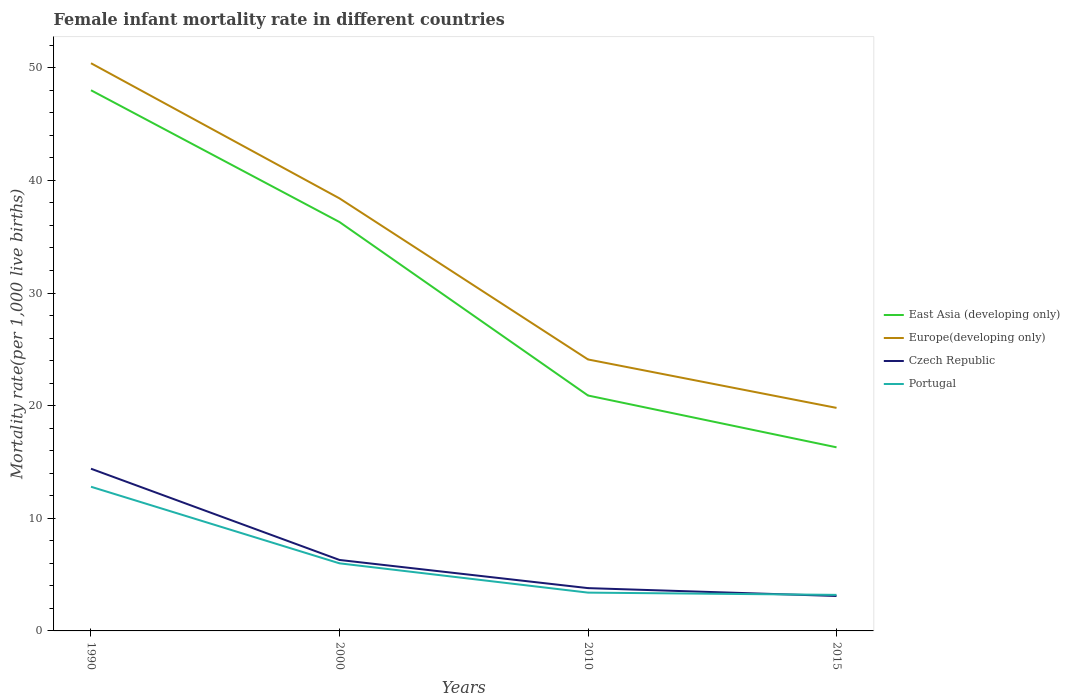Is the number of lines equal to the number of legend labels?
Offer a terse response. Yes. In which year was the female infant mortality rate in East Asia (developing only) maximum?
Your response must be concise. 2015. What is the total female infant mortality rate in Czech Republic in the graph?
Provide a short and direct response. 11.3. What is the difference between the highest and the second highest female infant mortality rate in Portugal?
Give a very brief answer. 9.6. Is the female infant mortality rate in East Asia (developing only) strictly greater than the female infant mortality rate in Portugal over the years?
Make the answer very short. No. How many lines are there?
Make the answer very short. 4. What is the difference between two consecutive major ticks on the Y-axis?
Ensure brevity in your answer.  10. Are the values on the major ticks of Y-axis written in scientific E-notation?
Offer a terse response. No. Does the graph contain any zero values?
Give a very brief answer. No. Does the graph contain grids?
Offer a terse response. No. Where does the legend appear in the graph?
Give a very brief answer. Center right. How many legend labels are there?
Make the answer very short. 4. What is the title of the graph?
Give a very brief answer. Female infant mortality rate in different countries. What is the label or title of the Y-axis?
Your answer should be compact. Mortality rate(per 1,0 live births). What is the Mortality rate(per 1,000 live births) of Europe(developing only) in 1990?
Make the answer very short. 50.4. What is the Mortality rate(per 1,000 live births) of Czech Republic in 1990?
Make the answer very short. 14.4. What is the Mortality rate(per 1,000 live births) of Portugal in 1990?
Give a very brief answer. 12.8. What is the Mortality rate(per 1,000 live births) of East Asia (developing only) in 2000?
Ensure brevity in your answer.  36.3. What is the Mortality rate(per 1,000 live births) of Europe(developing only) in 2000?
Your response must be concise. 38.4. What is the Mortality rate(per 1,000 live births) of Portugal in 2000?
Give a very brief answer. 6. What is the Mortality rate(per 1,000 live births) of East Asia (developing only) in 2010?
Provide a succinct answer. 20.9. What is the Mortality rate(per 1,000 live births) in Europe(developing only) in 2010?
Keep it short and to the point. 24.1. What is the Mortality rate(per 1,000 live births) of Czech Republic in 2010?
Offer a terse response. 3.8. What is the Mortality rate(per 1,000 live births) in East Asia (developing only) in 2015?
Provide a short and direct response. 16.3. What is the Mortality rate(per 1,000 live births) of Europe(developing only) in 2015?
Your answer should be very brief. 19.8. What is the Mortality rate(per 1,000 live births) of Czech Republic in 2015?
Offer a very short reply. 3.1. What is the Mortality rate(per 1,000 live births) in Portugal in 2015?
Make the answer very short. 3.2. Across all years, what is the maximum Mortality rate(per 1,000 live births) in Europe(developing only)?
Keep it short and to the point. 50.4. Across all years, what is the maximum Mortality rate(per 1,000 live births) in Czech Republic?
Offer a terse response. 14.4. Across all years, what is the maximum Mortality rate(per 1,000 live births) in Portugal?
Your response must be concise. 12.8. Across all years, what is the minimum Mortality rate(per 1,000 live births) of East Asia (developing only)?
Provide a short and direct response. 16.3. Across all years, what is the minimum Mortality rate(per 1,000 live births) in Europe(developing only)?
Ensure brevity in your answer.  19.8. Across all years, what is the minimum Mortality rate(per 1,000 live births) in Portugal?
Provide a short and direct response. 3.2. What is the total Mortality rate(per 1,000 live births) of East Asia (developing only) in the graph?
Provide a short and direct response. 121.5. What is the total Mortality rate(per 1,000 live births) of Europe(developing only) in the graph?
Give a very brief answer. 132.7. What is the total Mortality rate(per 1,000 live births) in Czech Republic in the graph?
Offer a very short reply. 27.6. What is the total Mortality rate(per 1,000 live births) in Portugal in the graph?
Your answer should be very brief. 25.4. What is the difference between the Mortality rate(per 1,000 live births) of East Asia (developing only) in 1990 and that in 2000?
Your answer should be very brief. 11.7. What is the difference between the Mortality rate(per 1,000 live births) in Europe(developing only) in 1990 and that in 2000?
Make the answer very short. 12. What is the difference between the Mortality rate(per 1,000 live births) in Portugal in 1990 and that in 2000?
Your response must be concise. 6.8. What is the difference between the Mortality rate(per 1,000 live births) in East Asia (developing only) in 1990 and that in 2010?
Your answer should be compact. 27.1. What is the difference between the Mortality rate(per 1,000 live births) of Europe(developing only) in 1990 and that in 2010?
Ensure brevity in your answer.  26.3. What is the difference between the Mortality rate(per 1,000 live births) in East Asia (developing only) in 1990 and that in 2015?
Your answer should be compact. 31.7. What is the difference between the Mortality rate(per 1,000 live births) of Europe(developing only) in 1990 and that in 2015?
Give a very brief answer. 30.6. What is the difference between the Mortality rate(per 1,000 live births) in Czech Republic in 1990 and that in 2015?
Provide a succinct answer. 11.3. What is the difference between the Mortality rate(per 1,000 live births) in East Asia (developing only) in 2000 and that in 2010?
Provide a succinct answer. 15.4. What is the difference between the Mortality rate(per 1,000 live births) in Europe(developing only) in 2000 and that in 2010?
Offer a very short reply. 14.3. What is the difference between the Mortality rate(per 1,000 live births) of Portugal in 2000 and that in 2010?
Provide a succinct answer. 2.6. What is the difference between the Mortality rate(per 1,000 live births) of East Asia (developing only) in 2000 and that in 2015?
Make the answer very short. 20. What is the difference between the Mortality rate(per 1,000 live births) of Europe(developing only) in 2000 and that in 2015?
Keep it short and to the point. 18.6. What is the difference between the Mortality rate(per 1,000 live births) of East Asia (developing only) in 2010 and that in 2015?
Keep it short and to the point. 4.6. What is the difference between the Mortality rate(per 1,000 live births) of Portugal in 2010 and that in 2015?
Keep it short and to the point. 0.2. What is the difference between the Mortality rate(per 1,000 live births) in East Asia (developing only) in 1990 and the Mortality rate(per 1,000 live births) in Europe(developing only) in 2000?
Your response must be concise. 9.6. What is the difference between the Mortality rate(per 1,000 live births) of East Asia (developing only) in 1990 and the Mortality rate(per 1,000 live births) of Czech Republic in 2000?
Your answer should be very brief. 41.7. What is the difference between the Mortality rate(per 1,000 live births) of East Asia (developing only) in 1990 and the Mortality rate(per 1,000 live births) of Portugal in 2000?
Make the answer very short. 42. What is the difference between the Mortality rate(per 1,000 live births) of Europe(developing only) in 1990 and the Mortality rate(per 1,000 live births) of Czech Republic in 2000?
Your response must be concise. 44.1. What is the difference between the Mortality rate(per 1,000 live births) of Europe(developing only) in 1990 and the Mortality rate(per 1,000 live births) of Portugal in 2000?
Ensure brevity in your answer.  44.4. What is the difference between the Mortality rate(per 1,000 live births) in East Asia (developing only) in 1990 and the Mortality rate(per 1,000 live births) in Europe(developing only) in 2010?
Your answer should be very brief. 23.9. What is the difference between the Mortality rate(per 1,000 live births) of East Asia (developing only) in 1990 and the Mortality rate(per 1,000 live births) of Czech Republic in 2010?
Keep it short and to the point. 44.2. What is the difference between the Mortality rate(per 1,000 live births) in East Asia (developing only) in 1990 and the Mortality rate(per 1,000 live births) in Portugal in 2010?
Keep it short and to the point. 44.6. What is the difference between the Mortality rate(per 1,000 live births) of Europe(developing only) in 1990 and the Mortality rate(per 1,000 live births) of Czech Republic in 2010?
Give a very brief answer. 46.6. What is the difference between the Mortality rate(per 1,000 live births) of Europe(developing only) in 1990 and the Mortality rate(per 1,000 live births) of Portugal in 2010?
Your answer should be very brief. 47. What is the difference between the Mortality rate(per 1,000 live births) of East Asia (developing only) in 1990 and the Mortality rate(per 1,000 live births) of Europe(developing only) in 2015?
Provide a succinct answer. 28.2. What is the difference between the Mortality rate(per 1,000 live births) of East Asia (developing only) in 1990 and the Mortality rate(per 1,000 live births) of Czech Republic in 2015?
Your answer should be compact. 44.9. What is the difference between the Mortality rate(per 1,000 live births) in East Asia (developing only) in 1990 and the Mortality rate(per 1,000 live births) in Portugal in 2015?
Give a very brief answer. 44.8. What is the difference between the Mortality rate(per 1,000 live births) of Europe(developing only) in 1990 and the Mortality rate(per 1,000 live births) of Czech Republic in 2015?
Offer a terse response. 47.3. What is the difference between the Mortality rate(per 1,000 live births) of Europe(developing only) in 1990 and the Mortality rate(per 1,000 live births) of Portugal in 2015?
Provide a short and direct response. 47.2. What is the difference between the Mortality rate(per 1,000 live births) of East Asia (developing only) in 2000 and the Mortality rate(per 1,000 live births) of Europe(developing only) in 2010?
Provide a succinct answer. 12.2. What is the difference between the Mortality rate(per 1,000 live births) of East Asia (developing only) in 2000 and the Mortality rate(per 1,000 live births) of Czech Republic in 2010?
Your response must be concise. 32.5. What is the difference between the Mortality rate(per 1,000 live births) of East Asia (developing only) in 2000 and the Mortality rate(per 1,000 live births) of Portugal in 2010?
Offer a very short reply. 32.9. What is the difference between the Mortality rate(per 1,000 live births) in Europe(developing only) in 2000 and the Mortality rate(per 1,000 live births) in Czech Republic in 2010?
Your answer should be compact. 34.6. What is the difference between the Mortality rate(per 1,000 live births) of East Asia (developing only) in 2000 and the Mortality rate(per 1,000 live births) of Czech Republic in 2015?
Keep it short and to the point. 33.2. What is the difference between the Mortality rate(per 1,000 live births) in East Asia (developing only) in 2000 and the Mortality rate(per 1,000 live births) in Portugal in 2015?
Ensure brevity in your answer.  33.1. What is the difference between the Mortality rate(per 1,000 live births) of Europe(developing only) in 2000 and the Mortality rate(per 1,000 live births) of Czech Republic in 2015?
Make the answer very short. 35.3. What is the difference between the Mortality rate(per 1,000 live births) in Europe(developing only) in 2000 and the Mortality rate(per 1,000 live births) in Portugal in 2015?
Your answer should be compact. 35.2. What is the difference between the Mortality rate(per 1,000 live births) of East Asia (developing only) in 2010 and the Mortality rate(per 1,000 live births) of Portugal in 2015?
Ensure brevity in your answer.  17.7. What is the difference between the Mortality rate(per 1,000 live births) of Europe(developing only) in 2010 and the Mortality rate(per 1,000 live births) of Portugal in 2015?
Your answer should be compact. 20.9. What is the difference between the Mortality rate(per 1,000 live births) of Czech Republic in 2010 and the Mortality rate(per 1,000 live births) of Portugal in 2015?
Keep it short and to the point. 0.6. What is the average Mortality rate(per 1,000 live births) of East Asia (developing only) per year?
Your answer should be compact. 30.38. What is the average Mortality rate(per 1,000 live births) of Europe(developing only) per year?
Your answer should be compact. 33.17. What is the average Mortality rate(per 1,000 live births) of Portugal per year?
Keep it short and to the point. 6.35. In the year 1990, what is the difference between the Mortality rate(per 1,000 live births) in East Asia (developing only) and Mortality rate(per 1,000 live births) in Czech Republic?
Your response must be concise. 33.6. In the year 1990, what is the difference between the Mortality rate(per 1,000 live births) of East Asia (developing only) and Mortality rate(per 1,000 live births) of Portugal?
Give a very brief answer. 35.2. In the year 1990, what is the difference between the Mortality rate(per 1,000 live births) in Europe(developing only) and Mortality rate(per 1,000 live births) in Czech Republic?
Your response must be concise. 36. In the year 1990, what is the difference between the Mortality rate(per 1,000 live births) in Europe(developing only) and Mortality rate(per 1,000 live births) in Portugal?
Your response must be concise. 37.6. In the year 2000, what is the difference between the Mortality rate(per 1,000 live births) in East Asia (developing only) and Mortality rate(per 1,000 live births) in Europe(developing only)?
Provide a short and direct response. -2.1. In the year 2000, what is the difference between the Mortality rate(per 1,000 live births) in East Asia (developing only) and Mortality rate(per 1,000 live births) in Portugal?
Offer a terse response. 30.3. In the year 2000, what is the difference between the Mortality rate(per 1,000 live births) of Europe(developing only) and Mortality rate(per 1,000 live births) of Czech Republic?
Keep it short and to the point. 32.1. In the year 2000, what is the difference between the Mortality rate(per 1,000 live births) of Europe(developing only) and Mortality rate(per 1,000 live births) of Portugal?
Your response must be concise. 32.4. In the year 2010, what is the difference between the Mortality rate(per 1,000 live births) of East Asia (developing only) and Mortality rate(per 1,000 live births) of Europe(developing only)?
Give a very brief answer. -3.2. In the year 2010, what is the difference between the Mortality rate(per 1,000 live births) in East Asia (developing only) and Mortality rate(per 1,000 live births) in Portugal?
Provide a succinct answer. 17.5. In the year 2010, what is the difference between the Mortality rate(per 1,000 live births) in Europe(developing only) and Mortality rate(per 1,000 live births) in Czech Republic?
Give a very brief answer. 20.3. In the year 2010, what is the difference between the Mortality rate(per 1,000 live births) in Europe(developing only) and Mortality rate(per 1,000 live births) in Portugal?
Your answer should be very brief. 20.7. In the year 2015, what is the difference between the Mortality rate(per 1,000 live births) in East Asia (developing only) and Mortality rate(per 1,000 live births) in Czech Republic?
Your answer should be very brief. 13.2. In the year 2015, what is the difference between the Mortality rate(per 1,000 live births) of Europe(developing only) and Mortality rate(per 1,000 live births) of Czech Republic?
Offer a terse response. 16.7. What is the ratio of the Mortality rate(per 1,000 live births) in East Asia (developing only) in 1990 to that in 2000?
Offer a very short reply. 1.32. What is the ratio of the Mortality rate(per 1,000 live births) in Europe(developing only) in 1990 to that in 2000?
Offer a terse response. 1.31. What is the ratio of the Mortality rate(per 1,000 live births) of Czech Republic in 1990 to that in 2000?
Provide a succinct answer. 2.29. What is the ratio of the Mortality rate(per 1,000 live births) of Portugal in 1990 to that in 2000?
Offer a terse response. 2.13. What is the ratio of the Mortality rate(per 1,000 live births) of East Asia (developing only) in 1990 to that in 2010?
Make the answer very short. 2.3. What is the ratio of the Mortality rate(per 1,000 live births) in Europe(developing only) in 1990 to that in 2010?
Ensure brevity in your answer.  2.09. What is the ratio of the Mortality rate(per 1,000 live births) of Czech Republic in 1990 to that in 2010?
Provide a succinct answer. 3.79. What is the ratio of the Mortality rate(per 1,000 live births) in Portugal in 1990 to that in 2010?
Make the answer very short. 3.76. What is the ratio of the Mortality rate(per 1,000 live births) in East Asia (developing only) in 1990 to that in 2015?
Ensure brevity in your answer.  2.94. What is the ratio of the Mortality rate(per 1,000 live births) in Europe(developing only) in 1990 to that in 2015?
Keep it short and to the point. 2.55. What is the ratio of the Mortality rate(per 1,000 live births) of Czech Republic in 1990 to that in 2015?
Provide a succinct answer. 4.65. What is the ratio of the Mortality rate(per 1,000 live births) in East Asia (developing only) in 2000 to that in 2010?
Ensure brevity in your answer.  1.74. What is the ratio of the Mortality rate(per 1,000 live births) of Europe(developing only) in 2000 to that in 2010?
Ensure brevity in your answer.  1.59. What is the ratio of the Mortality rate(per 1,000 live births) in Czech Republic in 2000 to that in 2010?
Offer a very short reply. 1.66. What is the ratio of the Mortality rate(per 1,000 live births) of Portugal in 2000 to that in 2010?
Provide a short and direct response. 1.76. What is the ratio of the Mortality rate(per 1,000 live births) in East Asia (developing only) in 2000 to that in 2015?
Offer a very short reply. 2.23. What is the ratio of the Mortality rate(per 1,000 live births) in Europe(developing only) in 2000 to that in 2015?
Offer a terse response. 1.94. What is the ratio of the Mortality rate(per 1,000 live births) in Czech Republic in 2000 to that in 2015?
Give a very brief answer. 2.03. What is the ratio of the Mortality rate(per 1,000 live births) in Portugal in 2000 to that in 2015?
Make the answer very short. 1.88. What is the ratio of the Mortality rate(per 1,000 live births) of East Asia (developing only) in 2010 to that in 2015?
Your answer should be compact. 1.28. What is the ratio of the Mortality rate(per 1,000 live births) in Europe(developing only) in 2010 to that in 2015?
Provide a succinct answer. 1.22. What is the ratio of the Mortality rate(per 1,000 live births) of Czech Republic in 2010 to that in 2015?
Give a very brief answer. 1.23. What is the difference between the highest and the second highest Mortality rate(per 1,000 live births) in East Asia (developing only)?
Offer a terse response. 11.7. What is the difference between the highest and the second highest Mortality rate(per 1,000 live births) of Europe(developing only)?
Offer a very short reply. 12. What is the difference between the highest and the second highest Mortality rate(per 1,000 live births) in Czech Republic?
Offer a terse response. 8.1. What is the difference between the highest and the second highest Mortality rate(per 1,000 live births) of Portugal?
Your answer should be very brief. 6.8. What is the difference between the highest and the lowest Mortality rate(per 1,000 live births) in East Asia (developing only)?
Offer a terse response. 31.7. What is the difference between the highest and the lowest Mortality rate(per 1,000 live births) of Europe(developing only)?
Provide a short and direct response. 30.6. 